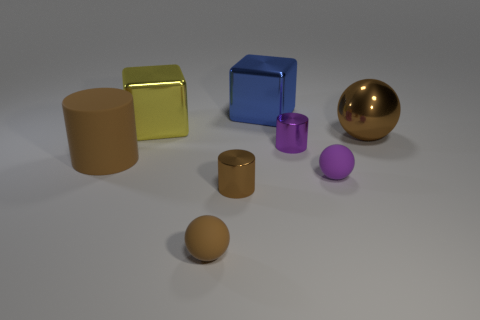Subtract all purple blocks. How many brown cylinders are left? 2 Subtract all shiny cylinders. How many cylinders are left? 1 Add 2 large green blocks. How many objects exist? 10 Subtract all balls. How many objects are left? 5 Subtract all big cubes. Subtract all yellow blocks. How many objects are left? 5 Add 1 purple shiny objects. How many purple shiny objects are left? 2 Add 1 large blue matte cylinders. How many large blue matte cylinders exist? 1 Subtract 1 brown cylinders. How many objects are left? 7 